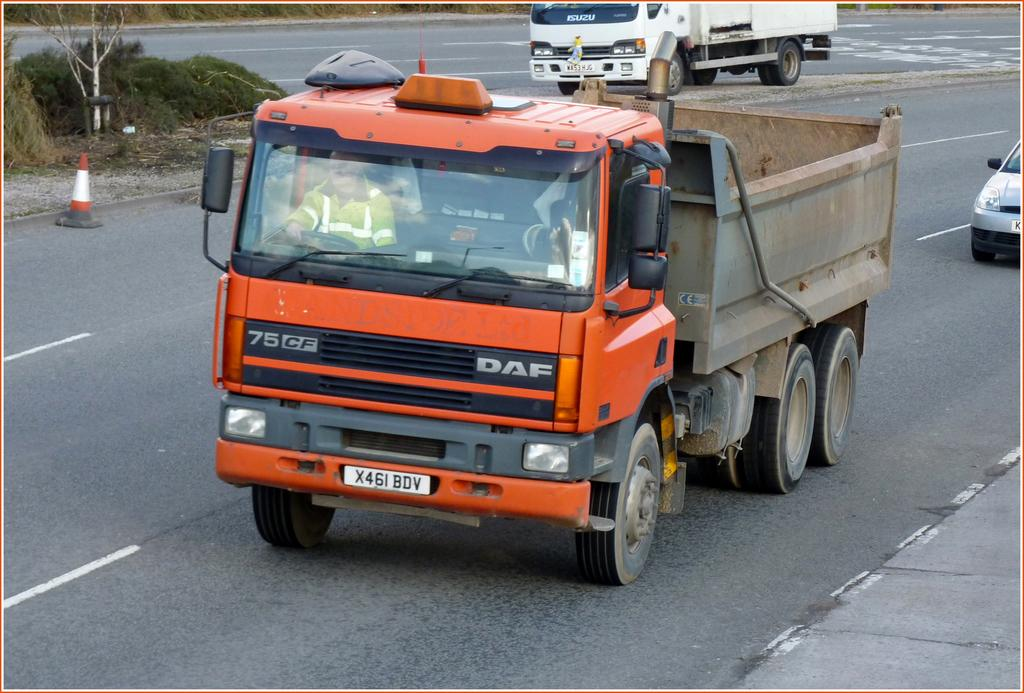What can be seen on the road in the image? There are vehicles on the road in the image. What object is present to guide or direct traffic? There is a traffic cone in the image. Can you describe the presence of a person in the image? There is a person inside a vehicle in the image. What type of natural elements can be seen in the image? There are plants visible in the image. What type of bucket is being used to apply force on the pan in the image? There is no bucket, force, or pan present in the image. 